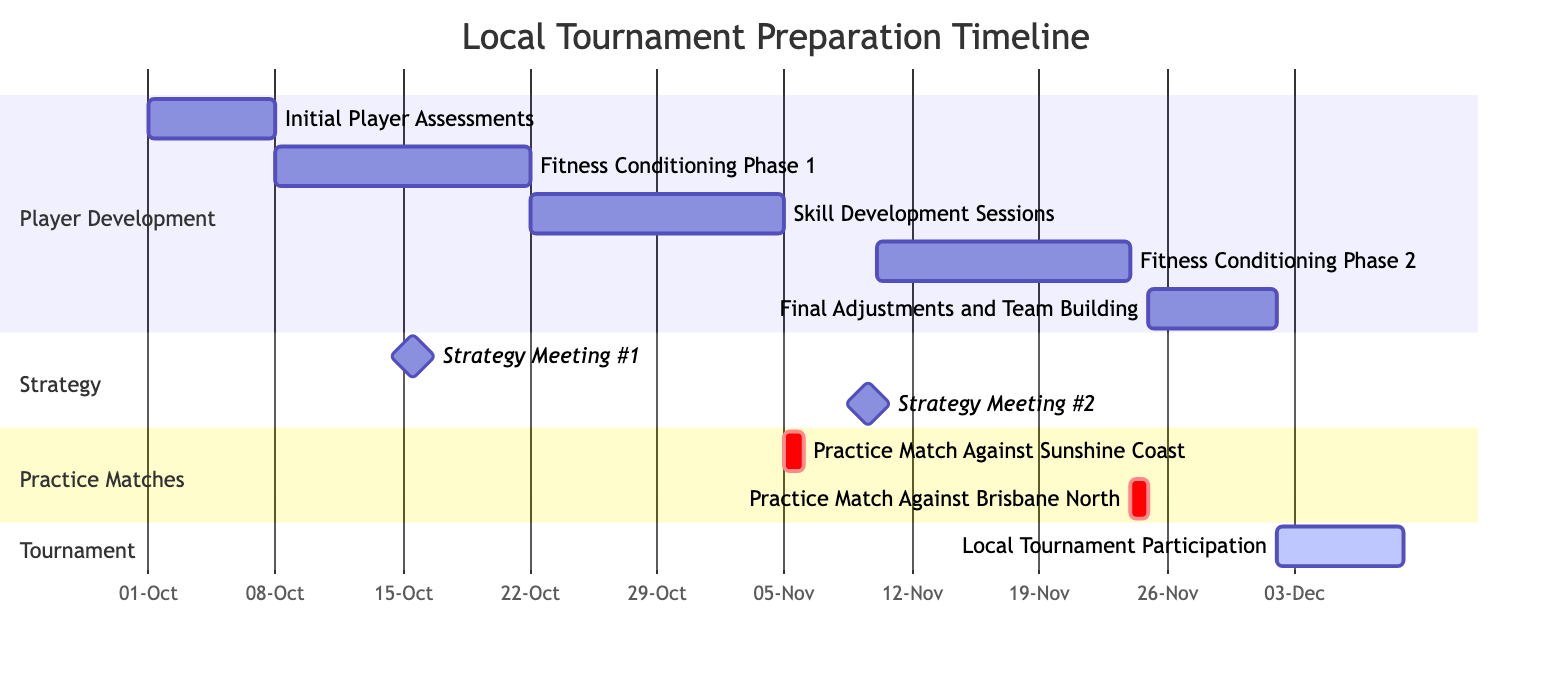What is the duration of the "Initial Player Assessments"? The "Initial Player Assessments" starts on October 1, 2023, and ends on October 7, 2023. This gives a duration of 7 days.
Answer: 7 days When is the first "Strategy Meeting"? The first "Strategy Meeting" is scheduled for October 15, 2023. This is indicated by the start and end date being the same.
Answer: October 15, 2023 How many practice matches are scheduled before the tournament? There are two practice matches listed: one against Sunshine Coast and another against Brisbane North.
Answer: 2 What phase starts right after "Fitness Conditioning Phase 1"? "Skill Development Sessions" starts immediately after "Fitness Conditioning Phase 1," which ends on October 21, and "Skill Development Sessions" begins on October 22.
Answer: Skill Development Sessions What is the timeline of the "Local Tournament Participation"? The "Local Tournament Participation" is scheduled from December 2, 2023, to December 8, 2023, covering a span of 7 days.
Answer: December 2, 2023 - December 8, 2023 Which activity overlaps with "Fitness Conditioning Phase 2"? "Strategy Meeting #2" on November 9, 2023, overlaps with "Fitness Conditioning Phase 2," which starts on November 10, 2023, and continues afterward.
Answer: Strategy Meeting #2 What is the starting date for "Final Adjustments and Team Building"? The "Final Adjustments and Team Building" phase starts on November 25, 2023, and lasts for 7 days.
Answer: November 25, 2023 What type of tasks are the "Practice Matches" classified as in the diagram? The "Practice Matches" are marked as critical tasks in the Gantt chart, as indicated by the "crit" designation next to their names.
Answer: Critical tasks How long is the total preparation timeline from "Initial Player Assessments" to "Local Tournament Participation"? The total preparation timeline spans from October 1, 2023, to December 8, 2023, which is 68 days in total.
Answer: 68 days 